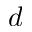<formula> <loc_0><loc_0><loc_500><loc_500>d</formula> 